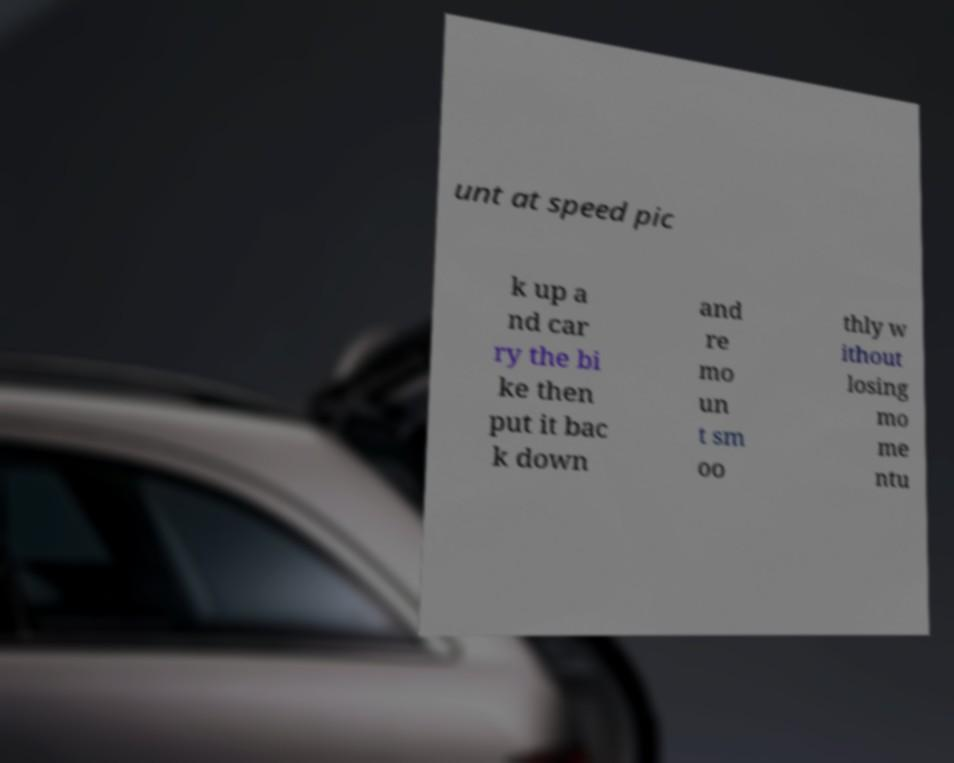There's text embedded in this image that I need extracted. Can you transcribe it verbatim? unt at speed pic k up a nd car ry the bi ke then put it bac k down and re mo un t sm oo thly w ithout losing mo me ntu 